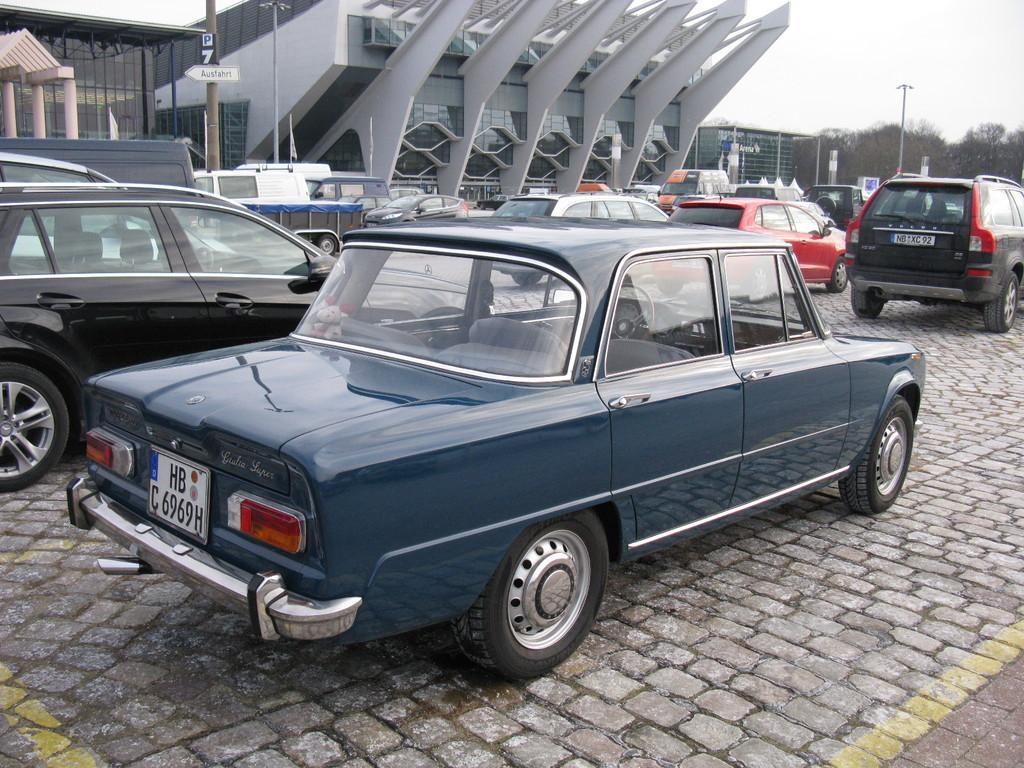How would you summarize this image in a sentence or two? In this image there are so many cars parked on the floor one beside the other in the rows. In the background there is a building. At the top there is the sky. On the right side top there are trees. There is a pole in front of the building. 